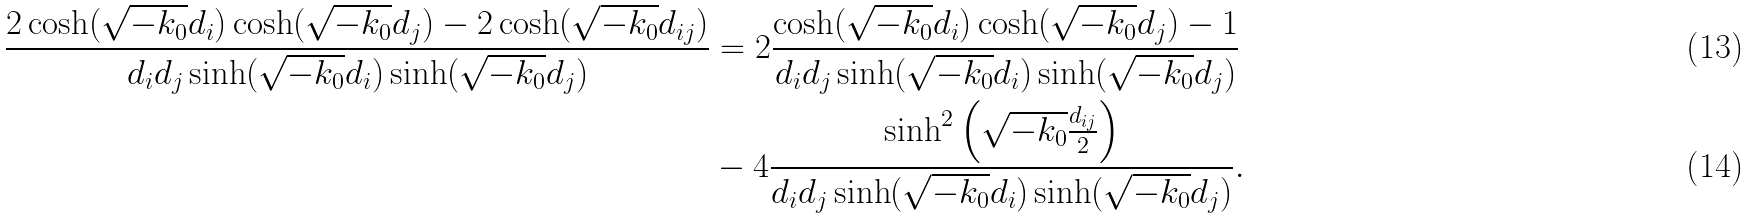<formula> <loc_0><loc_0><loc_500><loc_500>\frac { 2 \cosh ( \sqrt { - k _ { 0 } } d _ { i } ) \cosh ( \sqrt { - k _ { 0 } } d _ { j } ) - 2 \cosh ( \sqrt { - k _ { 0 } } d _ { i j } ) } { d _ { i } d _ { j } \sinh ( \sqrt { - k _ { 0 } } d _ { i } ) \sinh ( \sqrt { - k _ { 0 } } d _ { j } ) } & = 2 \frac { \cosh ( \sqrt { - k _ { 0 } } d _ { i } ) \cosh ( \sqrt { - k _ { 0 } } d _ { j } ) - 1 } { d _ { i } d _ { j } \sinh ( \sqrt { - k _ { 0 } } d _ { i } ) \sinh ( \sqrt { - k _ { 0 } } d _ { j } ) } \\ & - 4 \frac { \sinh ^ { 2 } \left ( \sqrt { - k _ { 0 } } \frac { d _ { i j } } { 2 } \right ) } { d _ { i } d _ { j } \sinh ( \sqrt { - k _ { 0 } } d _ { i } ) \sinh ( \sqrt { - k _ { 0 } } d _ { j } ) } .</formula> 